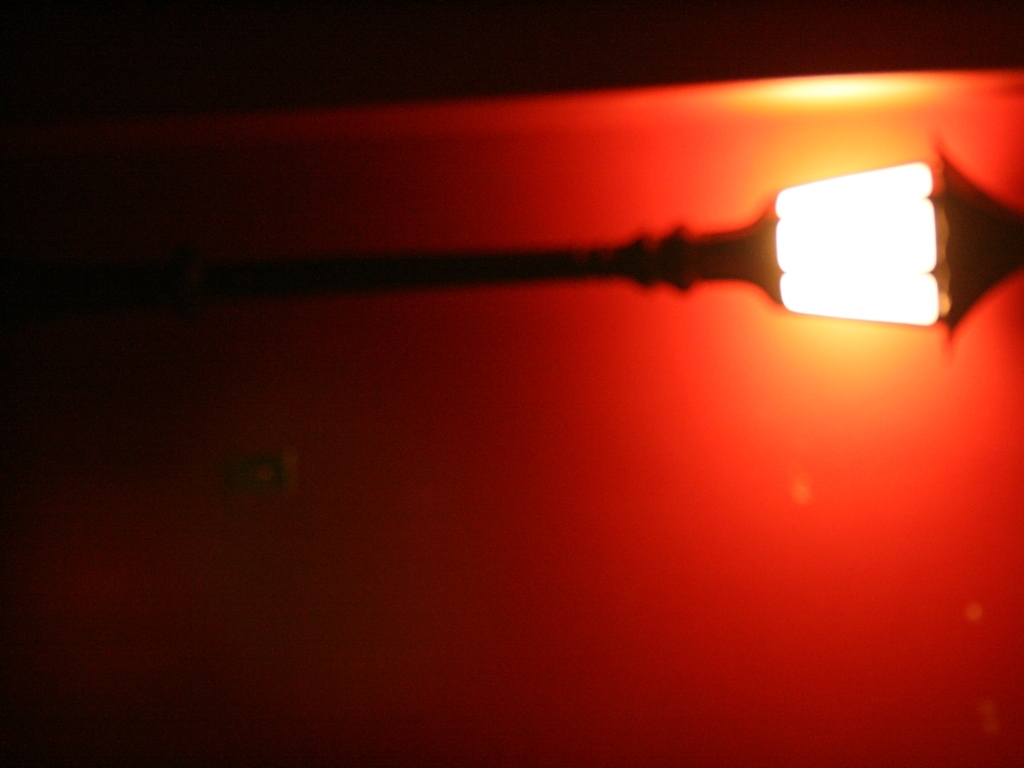What is the overall image clarity of this picture?
A. Average
B. Poor
C. Good
Answer with the option's letter from the given choices directly.
 B. 